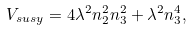<formula> <loc_0><loc_0><loc_500><loc_500>V _ { s u s y } = 4 \lambda ^ { 2 } n _ { 2 } ^ { 2 } n _ { 3 } ^ { 2 } + \lambda ^ { 2 } n _ { 3 } ^ { 4 } ,</formula> 